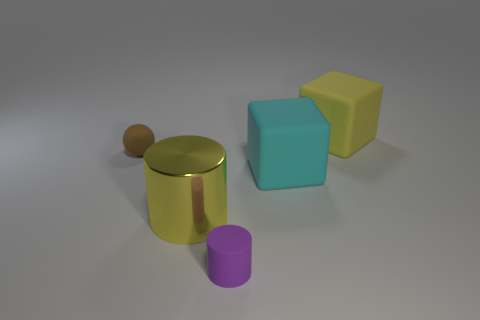The small purple object that is made of the same material as the brown ball is what shape?
Your response must be concise. Cylinder. Is the number of big cyan objects in front of the metallic cylinder less than the number of tiny brown cylinders?
Make the answer very short. No. The small thing that is to the left of the yellow cylinder is what color?
Your response must be concise. Brown. What material is the block that is the same color as the shiny cylinder?
Your answer should be very brief. Rubber. Is there another metal object of the same shape as the purple object?
Offer a terse response. Yes. What number of other tiny objects are the same shape as the yellow shiny object?
Provide a succinct answer. 1. Are there fewer metal objects than blue matte things?
Offer a very short reply. No. What is the material of the large object left of the cyan object?
Make the answer very short. Metal. There is a cylinder that is the same size as the yellow block; what is it made of?
Offer a very short reply. Metal. What material is the cylinder left of the rubber object in front of the large thing that is left of the purple rubber object?
Ensure brevity in your answer.  Metal. 